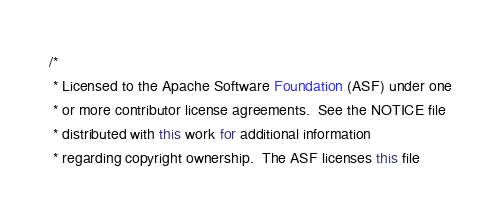Convert code to text. <code><loc_0><loc_0><loc_500><loc_500><_Java_>/*
 * Licensed to the Apache Software Foundation (ASF) under one
 * or more contributor license agreements.  See the NOTICE file
 * distributed with this work for additional information
 * regarding copyright ownership.  The ASF licenses this file</code> 